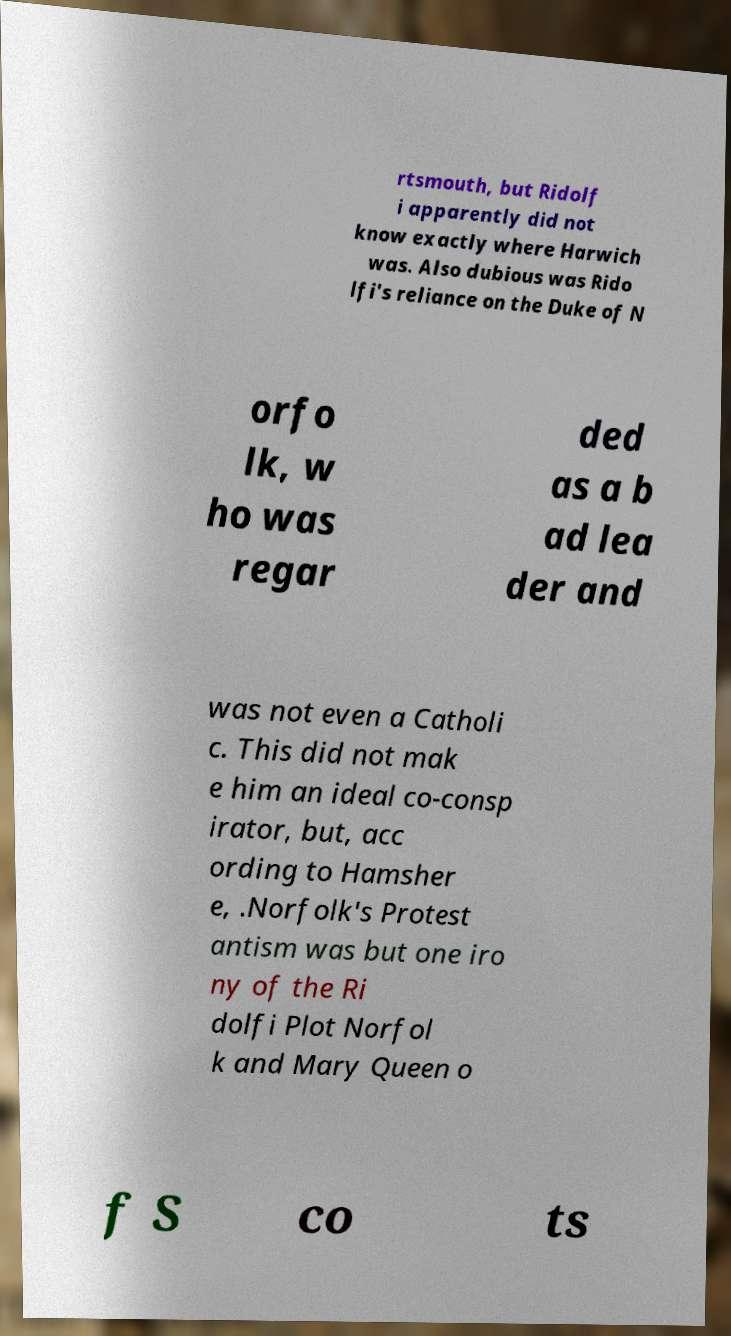There's text embedded in this image that I need extracted. Can you transcribe it verbatim? rtsmouth, but Ridolf i apparently did not know exactly where Harwich was. Also dubious was Rido lfi's reliance on the Duke of N orfo lk, w ho was regar ded as a b ad lea der and was not even a Catholi c. This did not mak e him an ideal co-consp irator, but, acc ording to Hamsher e, .Norfolk's Protest antism was but one iro ny of the Ri dolfi Plot Norfol k and Mary Queen o f S co ts 